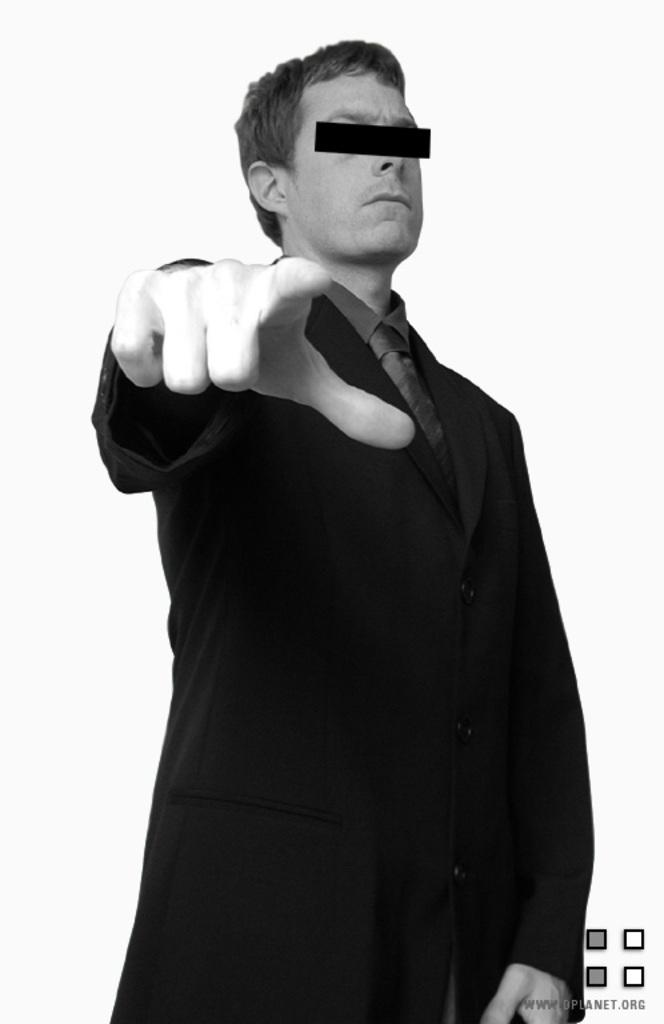Who is present in the image? There is a man in the image. What is the man wearing? The man is wearing a black suit. What color is the background of the image? The background of the image is white. Can you describe any distinguishing features on the man's face? There is a black mark on the man's eyes. What type of music can be heard playing in the background of the image? There is no music present in the image, as it is a still photograph. 